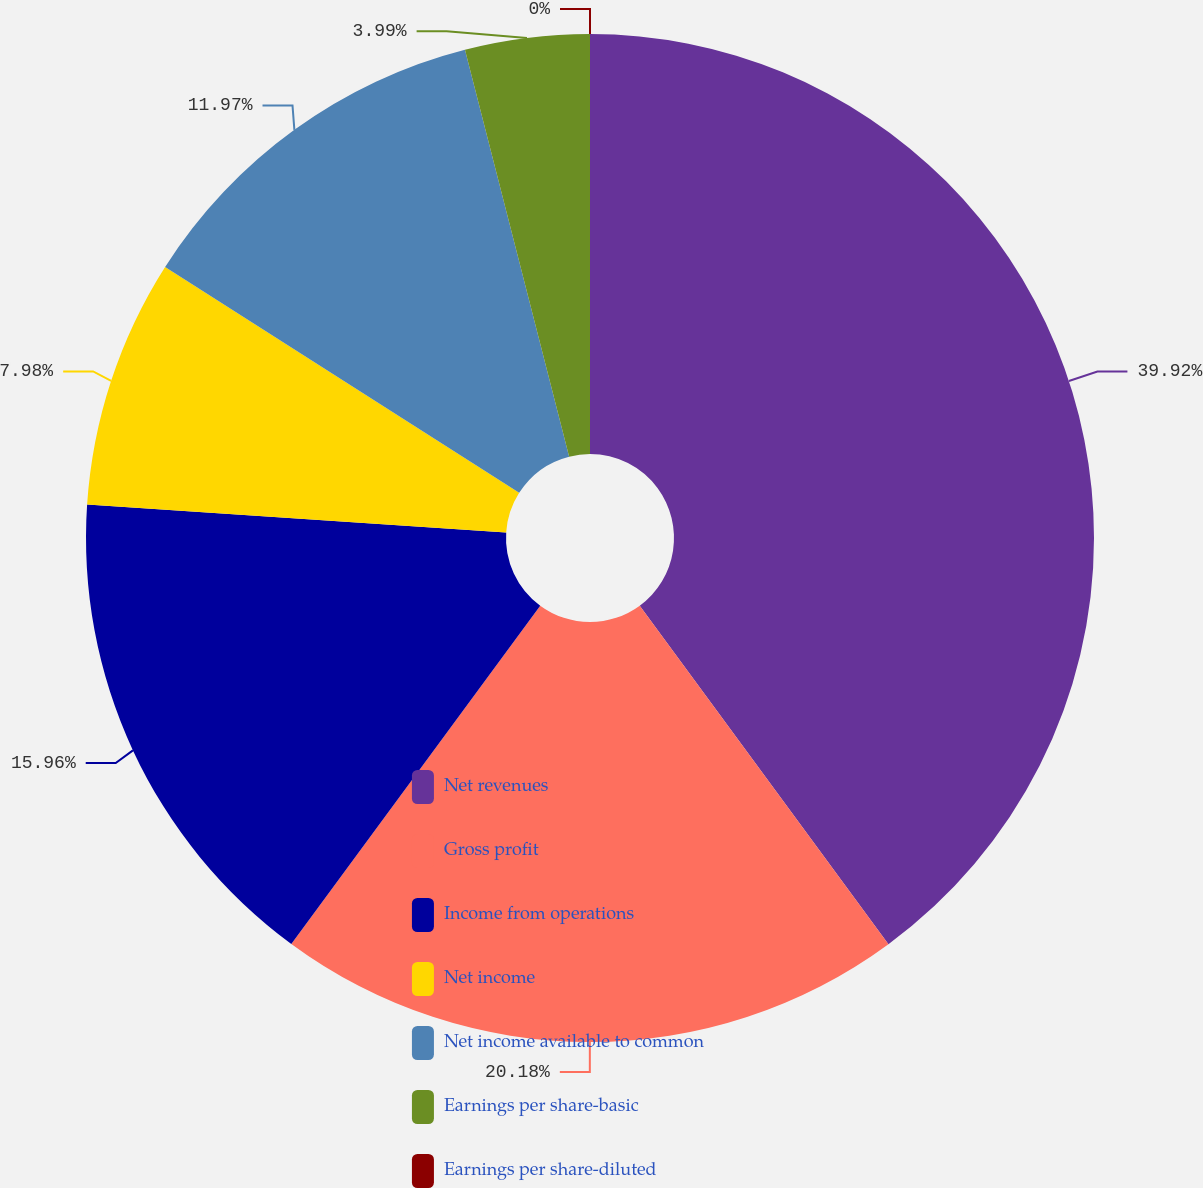<chart> <loc_0><loc_0><loc_500><loc_500><pie_chart><fcel>Net revenues<fcel>Gross profit<fcel>Income from operations<fcel>Net income<fcel>Net income available to common<fcel>Earnings per share-basic<fcel>Earnings per share-diluted<nl><fcel>39.91%<fcel>20.18%<fcel>15.96%<fcel>7.98%<fcel>11.97%<fcel>3.99%<fcel>0.0%<nl></chart> 